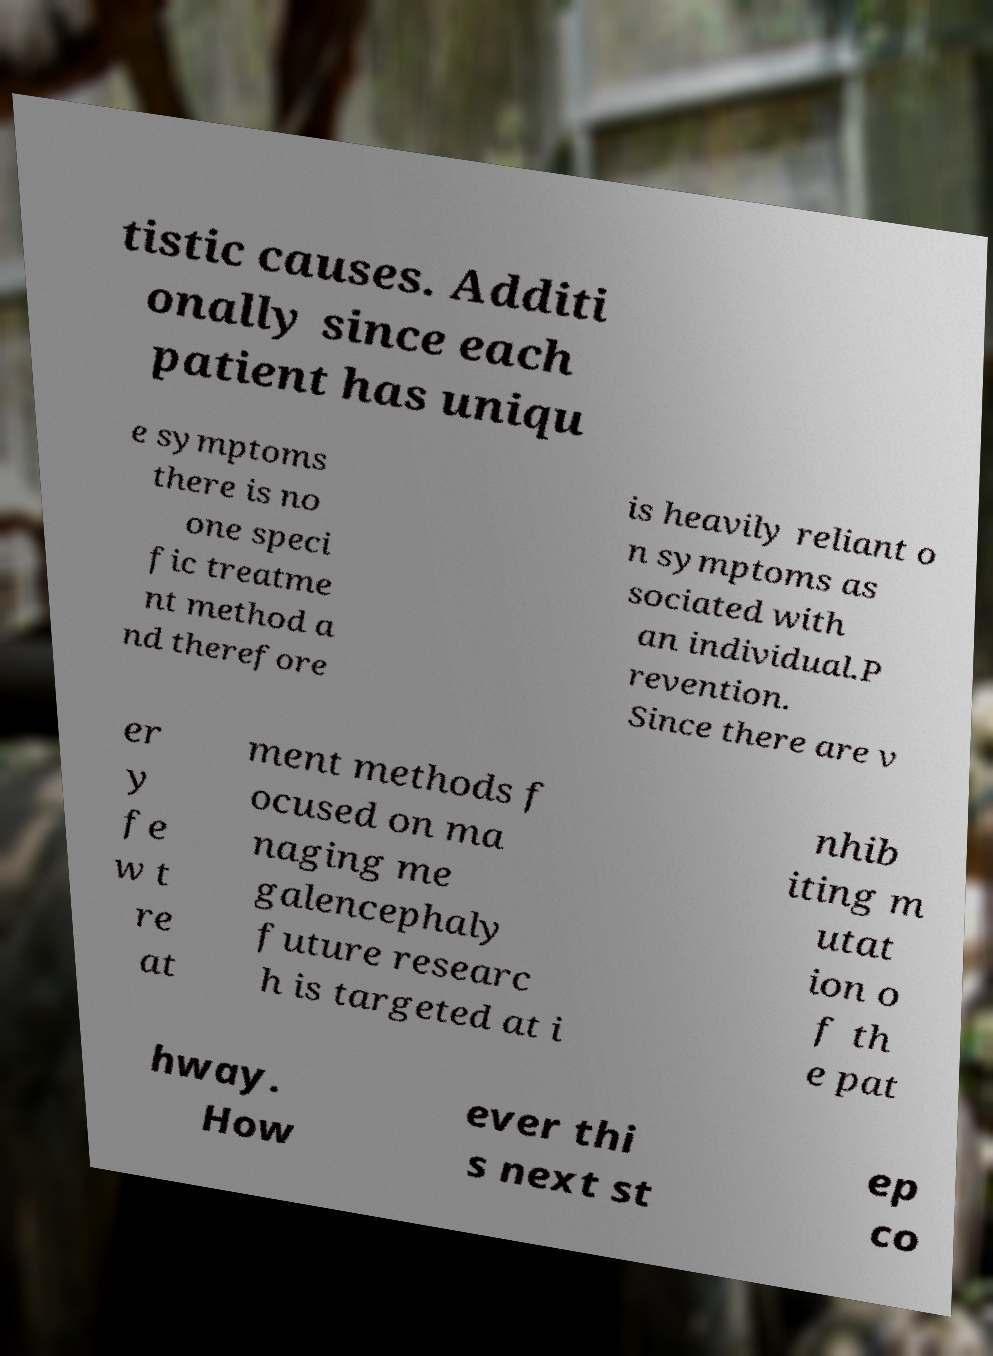Please read and relay the text visible in this image. What does it say? tistic causes. Additi onally since each patient has uniqu e symptoms there is no one speci fic treatme nt method a nd therefore is heavily reliant o n symptoms as sociated with an individual.P revention. Since there are v er y fe w t re at ment methods f ocused on ma naging me galencephaly future researc h is targeted at i nhib iting m utat ion o f th e pat hway. How ever thi s next st ep co 